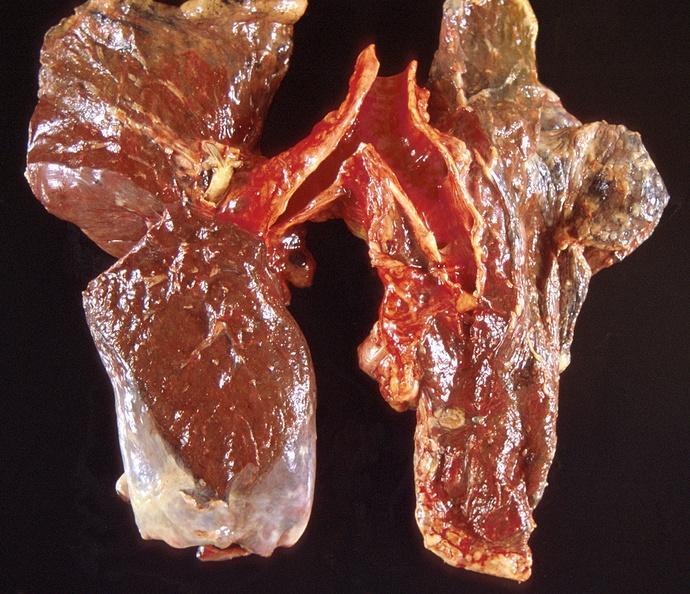s respiratory present?
Answer the question using a single word or phrase. Yes 